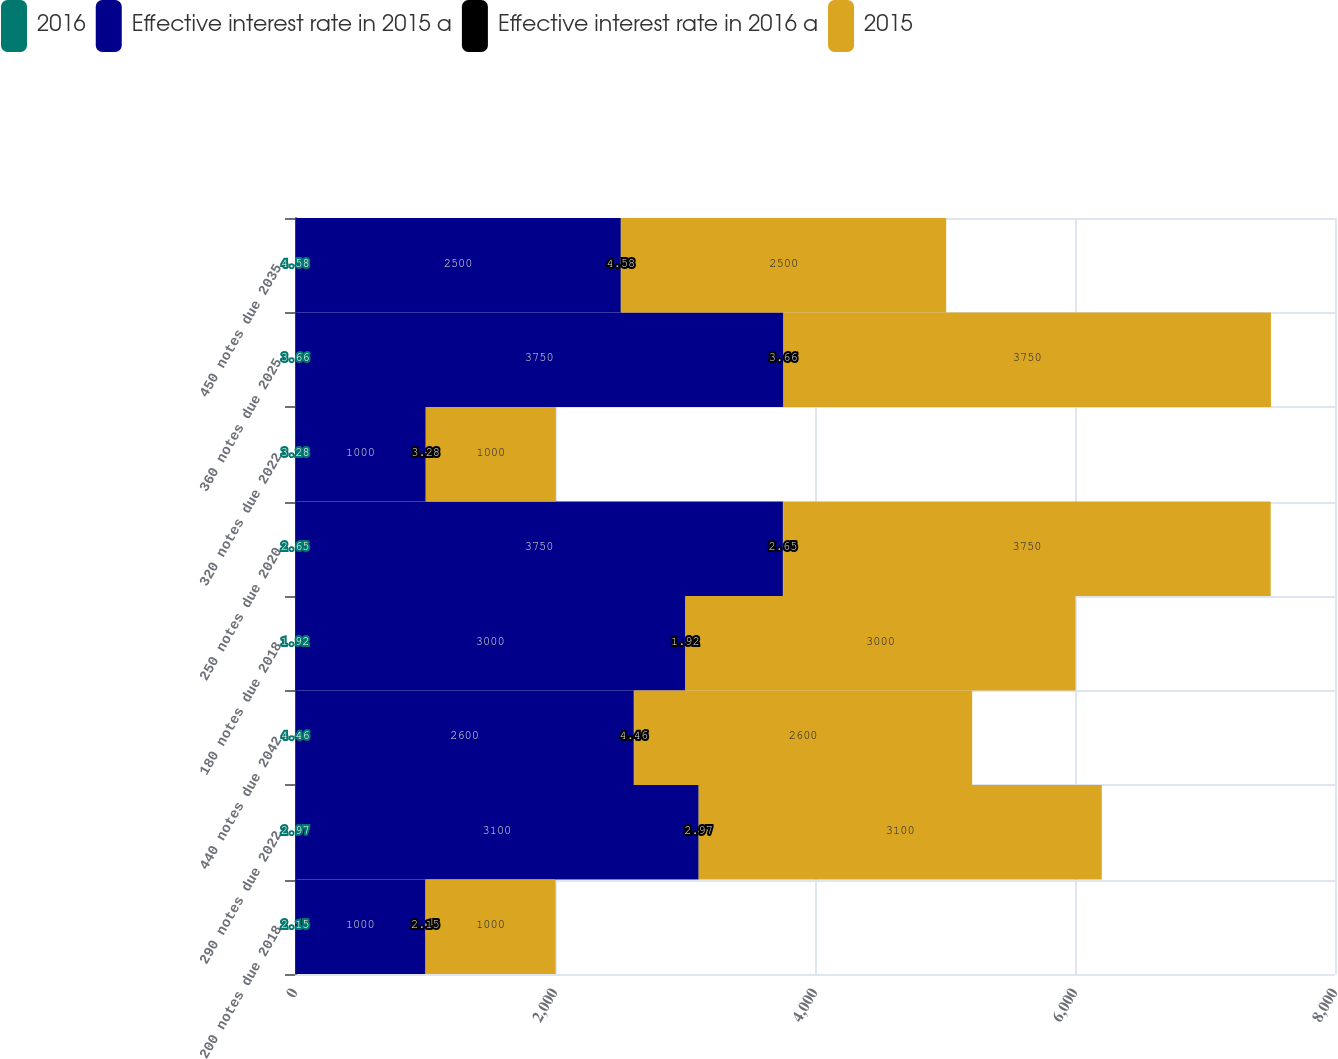<chart> <loc_0><loc_0><loc_500><loc_500><stacked_bar_chart><ecel><fcel>200 notes due 2018<fcel>290 notes due 2022<fcel>440 notes due 2042<fcel>180 notes due 2018<fcel>250 notes due 2020<fcel>320 notes due 2022<fcel>360 notes due 2025<fcel>450 notes due 2035<nl><fcel>2016<fcel>2.15<fcel>2.97<fcel>4.46<fcel>1.92<fcel>2.65<fcel>3.28<fcel>3.66<fcel>4.58<nl><fcel>Effective interest rate in 2015 a<fcel>1000<fcel>3100<fcel>2600<fcel>3000<fcel>3750<fcel>1000<fcel>3750<fcel>2500<nl><fcel>Effective interest rate in 2016 a<fcel>2.15<fcel>2.97<fcel>4.46<fcel>1.92<fcel>2.65<fcel>3.28<fcel>3.66<fcel>4.58<nl><fcel>2015<fcel>1000<fcel>3100<fcel>2600<fcel>3000<fcel>3750<fcel>1000<fcel>3750<fcel>2500<nl></chart> 